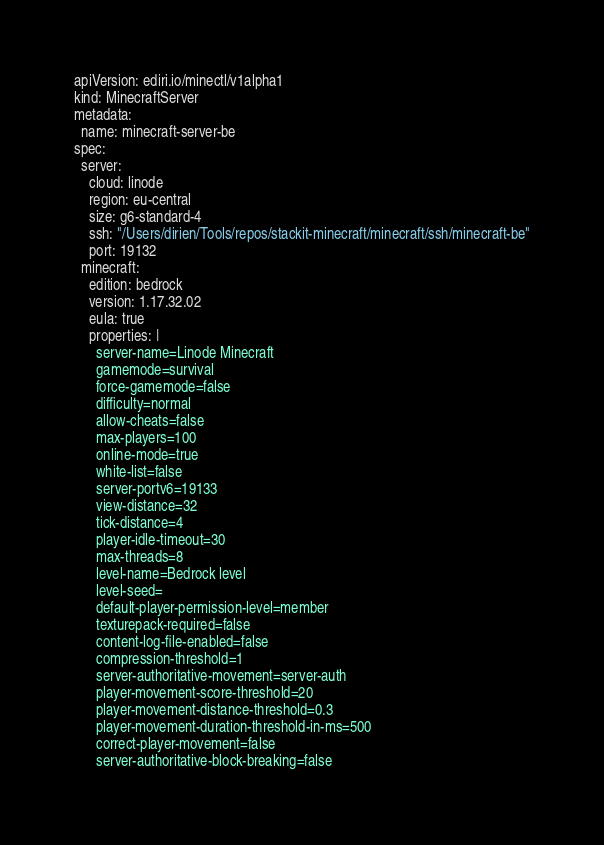<code> <loc_0><loc_0><loc_500><loc_500><_YAML_>apiVersion: ediri.io/minectl/v1alpha1
kind: MinecraftServer
metadata:
  name: minecraft-server-be
spec:
  server:
    cloud: linode
    region: eu-central
    size: g6-standard-4
    ssh: "/Users/dirien/Tools/repos/stackit-minecraft/minecraft/ssh/minecraft-be"
    port: 19132
  minecraft:
    edition: bedrock
    version: 1.17.32.02
    eula: true
    properties: |
      server-name=Linode Minecraft
      gamemode=survival
      force-gamemode=false
      difficulty=normal
      allow-cheats=false
      max-players=100
      online-mode=true
      white-list=false
      server-portv6=19133
      view-distance=32
      tick-distance=4
      player-idle-timeout=30
      max-threads=8
      level-name=Bedrock level
      level-seed=
      default-player-permission-level=member
      texturepack-required=false
      content-log-file-enabled=false
      compression-threshold=1
      server-authoritative-movement=server-auth
      player-movement-score-threshold=20
      player-movement-distance-threshold=0.3
      player-movement-duration-threshold-in-ms=500
      correct-player-movement=false
      server-authoritative-block-breaking=false
</code> 